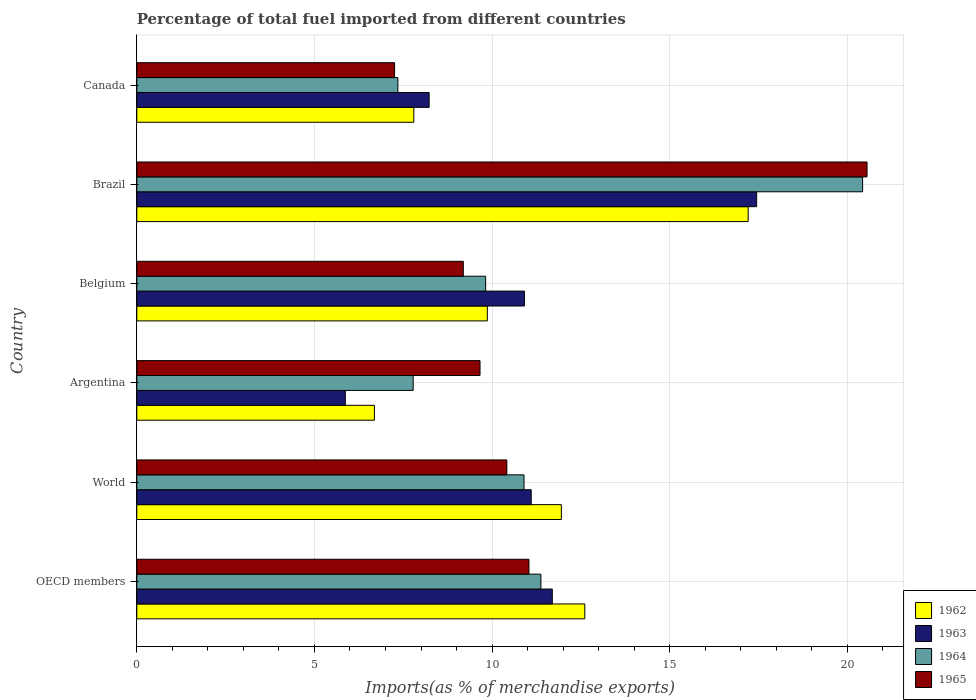How many different coloured bars are there?
Your response must be concise. 4. How many groups of bars are there?
Offer a very short reply. 6. Are the number of bars on each tick of the Y-axis equal?
Provide a succinct answer. Yes. How many bars are there on the 5th tick from the top?
Provide a succinct answer. 4. How many bars are there on the 6th tick from the bottom?
Give a very brief answer. 4. In how many cases, is the number of bars for a given country not equal to the number of legend labels?
Your answer should be compact. 0. What is the percentage of imports to different countries in 1965 in Belgium?
Your answer should be compact. 9.19. Across all countries, what is the maximum percentage of imports to different countries in 1965?
Ensure brevity in your answer.  20.55. Across all countries, what is the minimum percentage of imports to different countries in 1965?
Give a very brief answer. 7.26. In which country was the percentage of imports to different countries in 1964 maximum?
Provide a short and direct response. Brazil. In which country was the percentage of imports to different countries in 1962 minimum?
Provide a short and direct response. Argentina. What is the total percentage of imports to different countries in 1965 in the graph?
Ensure brevity in your answer.  68.12. What is the difference between the percentage of imports to different countries in 1962 in Belgium and that in Canada?
Make the answer very short. 2.07. What is the difference between the percentage of imports to different countries in 1962 in OECD members and the percentage of imports to different countries in 1964 in Canada?
Make the answer very short. 5.26. What is the average percentage of imports to different countries in 1964 per country?
Your answer should be very brief. 11.28. What is the difference between the percentage of imports to different countries in 1963 and percentage of imports to different countries in 1965 in World?
Your answer should be compact. 0.69. In how many countries, is the percentage of imports to different countries in 1965 greater than 7 %?
Ensure brevity in your answer.  6. What is the ratio of the percentage of imports to different countries in 1964 in Argentina to that in OECD members?
Give a very brief answer. 0.68. Is the percentage of imports to different countries in 1964 in OECD members less than that in World?
Your answer should be very brief. No. Is the difference between the percentage of imports to different countries in 1963 in Brazil and Canada greater than the difference between the percentage of imports to different countries in 1965 in Brazil and Canada?
Your response must be concise. No. What is the difference between the highest and the second highest percentage of imports to different countries in 1962?
Provide a succinct answer. 4.6. What is the difference between the highest and the lowest percentage of imports to different countries in 1965?
Your answer should be compact. 13.3. Is it the case that in every country, the sum of the percentage of imports to different countries in 1965 and percentage of imports to different countries in 1963 is greater than the sum of percentage of imports to different countries in 1962 and percentage of imports to different countries in 1964?
Provide a short and direct response. No. What does the 4th bar from the bottom in Belgium represents?
Provide a succinct answer. 1965. Is it the case that in every country, the sum of the percentage of imports to different countries in 1964 and percentage of imports to different countries in 1965 is greater than the percentage of imports to different countries in 1963?
Keep it short and to the point. Yes. How many bars are there?
Your answer should be compact. 24. Are all the bars in the graph horizontal?
Provide a short and direct response. Yes. Where does the legend appear in the graph?
Provide a short and direct response. Bottom right. How many legend labels are there?
Ensure brevity in your answer.  4. What is the title of the graph?
Your response must be concise. Percentage of total fuel imported from different countries. Does "1971" appear as one of the legend labels in the graph?
Make the answer very short. No. What is the label or title of the X-axis?
Offer a very short reply. Imports(as % of merchandise exports). What is the Imports(as % of merchandise exports) in 1962 in OECD members?
Offer a very short reply. 12.61. What is the Imports(as % of merchandise exports) of 1963 in OECD members?
Keep it short and to the point. 11.7. What is the Imports(as % of merchandise exports) in 1964 in OECD members?
Your response must be concise. 11.37. What is the Imports(as % of merchandise exports) of 1965 in OECD members?
Give a very brief answer. 11.04. What is the Imports(as % of merchandise exports) in 1962 in World?
Offer a very short reply. 11.95. What is the Imports(as % of merchandise exports) in 1963 in World?
Your response must be concise. 11.1. What is the Imports(as % of merchandise exports) of 1964 in World?
Your response must be concise. 10.9. What is the Imports(as % of merchandise exports) in 1965 in World?
Make the answer very short. 10.42. What is the Imports(as % of merchandise exports) of 1962 in Argentina?
Provide a short and direct response. 6.69. What is the Imports(as % of merchandise exports) of 1963 in Argentina?
Your response must be concise. 5.87. What is the Imports(as % of merchandise exports) of 1964 in Argentina?
Offer a terse response. 7.78. What is the Imports(as % of merchandise exports) in 1965 in Argentina?
Give a very brief answer. 9.66. What is the Imports(as % of merchandise exports) in 1962 in Belgium?
Make the answer very short. 9.87. What is the Imports(as % of merchandise exports) in 1963 in Belgium?
Keep it short and to the point. 10.91. What is the Imports(as % of merchandise exports) in 1964 in Belgium?
Ensure brevity in your answer.  9.82. What is the Imports(as % of merchandise exports) in 1965 in Belgium?
Provide a succinct answer. 9.19. What is the Imports(as % of merchandise exports) of 1962 in Brazil?
Ensure brevity in your answer.  17.21. What is the Imports(as % of merchandise exports) of 1963 in Brazil?
Your answer should be compact. 17.45. What is the Imports(as % of merchandise exports) of 1964 in Brazil?
Your response must be concise. 20.43. What is the Imports(as % of merchandise exports) of 1965 in Brazil?
Offer a very short reply. 20.55. What is the Imports(as % of merchandise exports) of 1962 in Canada?
Provide a succinct answer. 7.8. What is the Imports(as % of merchandise exports) of 1963 in Canada?
Give a very brief answer. 8.23. What is the Imports(as % of merchandise exports) of 1964 in Canada?
Provide a short and direct response. 7.35. What is the Imports(as % of merchandise exports) in 1965 in Canada?
Keep it short and to the point. 7.26. Across all countries, what is the maximum Imports(as % of merchandise exports) of 1962?
Provide a short and direct response. 17.21. Across all countries, what is the maximum Imports(as % of merchandise exports) in 1963?
Your answer should be compact. 17.45. Across all countries, what is the maximum Imports(as % of merchandise exports) in 1964?
Offer a terse response. 20.43. Across all countries, what is the maximum Imports(as % of merchandise exports) in 1965?
Keep it short and to the point. 20.55. Across all countries, what is the minimum Imports(as % of merchandise exports) of 1962?
Give a very brief answer. 6.69. Across all countries, what is the minimum Imports(as % of merchandise exports) of 1963?
Keep it short and to the point. 5.87. Across all countries, what is the minimum Imports(as % of merchandise exports) in 1964?
Your answer should be compact. 7.35. Across all countries, what is the minimum Imports(as % of merchandise exports) of 1965?
Provide a succinct answer. 7.26. What is the total Imports(as % of merchandise exports) of 1962 in the graph?
Ensure brevity in your answer.  66.12. What is the total Imports(as % of merchandise exports) in 1963 in the graph?
Give a very brief answer. 65.25. What is the total Imports(as % of merchandise exports) of 1964 in the graph?
Give a very brief answer. 67.65. What is the total Imports(as % of merchandise exports) of 1965 in the graph?
Keep it short and to the point. 68.12. What is the difference between the Imports(as % of merchandise exports) of 1962 in OECD members and that in World?
Your answer should be very brief. 0.66. What is the difference between the Imports(as % of merchandise exports) of 1963 in OECD members and that in World?
Offer a very short reply. 0.59. What is the difference between the Imports(as % of merchandise exports) in 1964 in OECD members and that in World?
Ensure brevity in your answer.  0.48. What is the difference between the Imports(as % of merchandise exports) of 1965 in OECD members and that in World?
Your answer should be very brief. 0.62. What is the difference between the Imports(as % of merchandise exports) in 1962 in OECD members and that in Argentina?
Your answer should be compact. 5.92. What is the difference between the Imports(as % of merchandise exports) in 1963 in OECD members and that in Argentina?
Provide a short and direct response. 5.83. What is the difference between the Imports(as % of merchandise exports) in 1964 in OECD members and that in Argentina?
Keep it short and to the point. 3.59. What is the difference between the Imports(as % of merchandise exports) in 1965 in OECD members and that in Argentina?
Give a very brief answer. 1.38. What is the difference between the Imports(as % of merchandise exports) of 1962 in OECD members and that in Belgium?
Your answer should be compact. 2.74. What is the difference between the Imports(as % of merchandise exports) in 1963 in OECD members and that in Belgium?
Provide a succinct answer. 0.79. What is the difference between the Imports(as % of merchandise exports) in 1964 in OECD members and that in Belgium?
Keep it short and to the point. 1.56. What is the difference between the Imports(as % of merchandise exports) of 1965 in OECD members and that in Belgium?
Provide a succinct answer. 1.85. What is the difference between the Imports(as % of merchandise exports) in 1962 in OECD members and that in Brazil?
Offer a very short reply. -4.6. What is the difference between the Imports(as % of merchandise exports) in 1963 in OECD members and that in Brazil?
Ensure brevity in your answer.  -5.75. What is the difference between the Imports(as % of merchandise exports) of 1964 in OECD members and that in Brazil?
Your response must be concise. -9.06. What is the difference between the Imports(as % of merchandise exports) in 1965 in OECD members and that in Brazil?
Ensure brevity in your answer.  -9.52. What is the difference between the Imports(as % of merchandise exports) in 1962 in OECD members and that in Canada?
Provide a succinct answer. 4.81. What is the difference between the Imports(as % of merchandise exports) of 1963 in OECD members and that in Canada?
Keep it short and to the point. 3.47. What is the difference between the Imports(as % of merchandise exports) of 1964 in OECD members and that in Canada?
Offer a very short reply. 4.03. What is the difference between the Imports(as % of merchandise exports) of 1965 in OECD members and that in Canada?
Your answer should be compact. 3.78. What is the difference between the Imports(as % of merchandise exports) of 1962 in World and that in Argentina?
Your answer should be very brief. 5.26. What is the difference between the Imports(as % of merchandise exports) in 1963 in World and that in Argentina?
Provide a succinct answer. 5.23. What is the difference between the Imports(as % of merchandise exports) of 1964 in World and that in Argentina?
Your answer should be very brief. 3.12. What is the difference between the Imports(as % of merchandise exports) of 1965 in World and that in Argentina?
Offer a terse response. 0.76. What is the difference between the Imports(as % of merchandise exports) in 1962 in World and that in Belgium?
Offer a terse response. 2.08. What is the difference between the Imports(as % of merchandise exports) in 1963 in World and that in Belgium?
Your answer should be compact. 0.19. What is the difference between the Imports(as % of merchandise exports) of 1964 in World and that in Belgium?
Keep it short and to the point. 1.08. What is the difference between the Imports(as % of merchandise exports) of 1965 in World and that in Belgium?
Your response must be concise. 1.23. What is the difference between the Imports(as % of merchandise exports) in 1962 in World and that in Brazil?
Keep it short and to the point. -5.26. What is the difference between the Imports(as % of merchandise exports) of 1963 in World and that in Brazil?
Provide a succinct answer. -6.34. What is the difference between the Imports(as % of merchandise exports) in 1964 in World and that in Brazil?
Your answer should be compact. -9.53. What is the difference between the Imports(as % of merchandise exports) of 1965 in World and that in Brazil?
Offer a very short reply. -10.14. What is the difference between the Imports(as % of merchandise exports) in 1962 in World and that in Canada?
Provide a succinct answer. 4.15. What is the difference between the Imports(as % of merchandise exports) of 1963 in World and that in Canada?
Ensure brevity in your answer.  2.87. What is the difference between the Imports(as % of merchandise exports) in 1964 in World and that in Canada?
Your answer should be compact. 3.55. What is the difference between the Imports(as % of merchandise exports) of 1965 in World and that in Canada?
Keep it short and to the point. 3.16. What is the difference between the Imports(as % of merchandise exports) of 1962 in Argentina and that in Belgium?
Provide a short and direct response. -3.18. What is the difference between the Imports(as % of merchandise exports) in 1963 in Argentina and that in Belgium?
Your answer should be very brief. -5.04. What is the difference between the Imports(as % of merchandise exports) of 1964 in Argentina and that in Belgium?
Provide a succinct answer. -2.04. What is the difference between the Imports(as % of merchandise exports) of 1965 in Argentina and that in Belgium?
Your answer should be very brief. 0.47. What is the difference between the Imports(as % of merchandise exports) of 1962 in Argentina and that in Brazil?
Your response must be concise. -10.52. What is the difference between the Imports(as % of merchandise exports) in 1963 in Argentina and that in Brazil?
Provide a short and direct response. -11.58. What is the difference between the Imports(as % of merchandise exports) of 1964 in Argentina and that in Brazil?
Provide a short and direct response. -12.65. What is the difference between the Imports(as % of merchandise exports) in 1965 in Argentina and that in Brazil?
Keep it short and to the point. -10.89. What is the difference between the Imports(as % of merchandise exports) in 1962 in Argentina and that in Canada?
Offer a very short reply. -1.11. What is the difference between the Imports(as % of merchandise exports) in 1963 in Argentina and that in Canada?
Provide a succinct answer. -2.36. What is the difference between the Imports(as % of merchandise exports) in 1964 in Argentina and that in Canada?
Offer a terse response. 0.43. What is the difference between the Imports(as % of merchandise exports) in 1965 in Argentina and that in Canada?
Ensure brevity in your answer.  2.4. What is the difference between the Imports(as % of merchandise exports) in 1962 in Belgium and that in Brazil?
Ensure brevity in your answer.  -7.34. What is the difference between the Imports(as % of merchandise exports) of 1963 in Belgium and that in Brazil?
Your answer should be compact. -6.54. What is the difference between the Imports(as % of merchandise exports) of 1964 in Belgium and that in Brazil?
Give a very brief answer. -10.61. What is the difference between the Imports(as % of merchandise exports) of 1965 in Belgium and that in Brazil?
Provide a short and direct response. -11.36. What is the difference between the Imports(as % of merchandise exports) of 1962 in Belgium and that in Canada?
Ensure brevity in your answer.  2.07. What is the difference between the Imports(as % of merchandise exports) of 1963 in Belgium and that in Canada?
Offer a terse response. 2.68. What is the difference between the Imports(as % of merchandise exports) in 1964 in Belgium and that in Canada?
Your answer should be compact. 2.47. What is the difference between the Imports(as % of merchandise exports) of 1965 in Belgium and that in Canada?
Ensure brevity in your answer.  1.93. What is the difference between the Imports(as % of merchandise exports) of 1962 in Brazil and that in Canada?
Keep it short and to the point. 9.41. What is the difference between the Imports(as % of merchandise exports) in 1963 in Brazil and that in Canada?
Offer a terse response. 9.22. What is the difference between the Imports(as % of merchandise exports) in 1964 in Brazil and that in Canada?
Make the answer very short. 13.08. What is the difference between the Imports(as % of merchandise exports) in 1965 in Brazil and that in Canada?
Your answer should be compact. 13.3. What is the difference between the Imports(as % of merchandise exports) of 1962 in OECD members and the Imports(as % of merchandise exports) of 1963 in World?
Offer a terse response. 1.51. What is the difference between the Imports(as % of merchandise exports) of 1962 in OECD members and the Imports(as % of merchandise exports) of 1964 in World?
Your answer should be very brief. 1.71. What is the difference between the Imports(as % of merchandise exports) in 1962 in OECD members and the Imports(as % of merchandise exports) in 1965 in World?
Make the answer very short. 2.19. What is the difference between the Imports(as % of merchandise exports) of 1963 in OECD members and the Imports(as % of merchandise exports) of 1964 in World?
Your response must be concise. 0.8. What is the difference between the Imports(as % of merchandise exports) in 1963 in OECD members and the Imports(as % of merchandise exports) in 1965 in World?
Offer a terse response. 1.28. What is the difference between the Imports(as % of merchandise exports) of 1964 in OECD members and the Imports(as % of merchandise exports) of 1965 in World?
Ensure brevity in your answer.  0.96. What is the difference between the Imports(as % of merchandise exports) of 1962 in OECD members and the Imports(as % of merchandise exports) of 1963 in Argentina?
Offer a very short reply. 6.74. What is the difference between the Imports(as % of merchandise exports) in 1962 in OECD members and the Imports(as % of merchandise exports) in 1964 in Argentina?
Ensure brevity in your answer.  4.83. What is the difference between the Imports(as % of merchandise exports) of 1962 in OECD members and the Imports(as % of merchandise exports) of 1965 in Argentina?
Give a very brief answer. 2.95. What is the difference between the Imports(as % of merchandise exports) of 1963 in OECD members and the Imports(as % of merchandise exports) of 1964 in Argentina?
Make the answer very short. 3.92. What is the difference between the Imports(as % of merchandise exports) in 1963 in OECD members and the Imports(as % of merchandise exports) in 1965 in Argentina?
Offer a very short reply. 2.04. What is the difference between the Imports(as % of merchandise exports) of 1964 in OECD members and the Imports(as % of merchandise exports) of 1965 in Argentina?
Provide a short and direct response. 1.71. What is the difference between the Imports(as % of merchandise exports) of 1962 in OECD members and the Imports(as % of merchandise exports) of 1963 in Belgium?
Your response must be concise. 1.7. What is the difference between the Imports(as % of merchandise exports) of 1962 in OECD members and the Imports(as % of merchandise exports) of 1964 in Belgium?
Provide a short and direct response. 2.79. What is the difference between the Imports(as % of merchandise exports) of 1962 in OECD members and the Imports(as % of merchandise exports) of 1965 in Belgium?
Provide a succinct answer. 3.42. What is the difference between the Imports(as % of merchandise exports) of 1963 in OECD members and the Imports(as % of merchandise exports) of 1964 in Belgium?
Offer a very short reply. 1.88. What is the difference between the Imports(as % of merchandise exports) in 1963 in OECD members and the Imports(as % of merchandise exports) in 1965 in Belgium?
Give a very brief answer. 2.51. What is the difference between the Imports(as % of merchandise exports) of 1964 in OECD members and the Imports(as % of merchandise exports) of 1965 in Belgium?
Make the answer very short. 2.18. What is the difference between the Imports(as % of merchandise exports) of 1962 in OECD members and the Imports(as % of merchandise exports) of 1963 in Brazil?
Your answer should be very brief. -4.84. What is the difference between the Imports(as % of merchandise exports) in 1962 in OECD members and the Imports(as % of merchandise exports) in 1964 in Brazil?
Give a very brief answer. -7.82. What is the difference between the Imports(as % of merchandise exports) of 1962 in OECD members and the Imports(as % of merchandise exports) of 1965 in Brazil?
Offer a very short reply. -7.94. What is the difference between the Imports(as % of merchandise exports) of 1963 in OECD members and the Imports(as % of merchandise exports) of 1964 in Brazil?
Keep it short and to the point. -8.73. What is the difference between the Imports(as % of merchandise exports) in 1963 in OECD members and the Imports(as % of merchandise exports) in 1965 in Brazil?
Ensure brevity in your answer.  -8.86. What is the difference between the Imports(as % of merchandise exports) of 1964 in OECD members and the Imports(as % of merchandise exports) of 1965 in Brazil?
Your response must be concise. -9.18. What is the difference between the Imports(as % of merchandise exports) in 1962 in OECD members and the Imports(as % of merchandise exports) in 1963 in Canada?
Offer a very short reply. 4.38. What is the difference between the Imports(as % of merchandise exports) of 1962 in OECD members and the Imports(as % of merchandise exports) of 1964 in Canada?
Keep it short and to the point. 5.26. What is the difference between the Imports(as % of merchandise exports) in 1962 in OECD members and the Imports(as % of merchandise exports) in 1965 in Canada?
Your answer should be compact. 5.35. What is the difference between the Imports(as % of merchandise exports) of 1963 in OECD members and the Imports(as % of merchandise exports) of 1964 in Canada?
Make the answer very short. 4.35. What is the difference between the Imports(as % of merchandise exports) of 1963 in OECD members and the Imports(as % of merchandise exports) of 1965 in Canada?
Ensure brevity in your answer.  4.44. What is the difference between the Imports(as % of merchandise exports) in 1964 in OECD members and the Imports(as % of merchandise exports) in 1965 in Canada?
Ensure brevity in your answer.  4.12. What is the difference between the Imports(as % of merchandise exports) in 1962 in World and the Imports(as % of merchandise exports) in 1963 in Argentina?
Your response must be concise. 6.08. What is the difference between the Imports(as % of merchandise exports) of 1962 in World and the Imports(as % of merchandise exports) of 1964 in Argentina?
Provide a succinct answer. 4.17. What is the difference between the Imports(as % of merchandise exports) of 1962 in World and the Imports(as % of merchandise exports) of 1965 in Argentina?
Make the answer very short. 2.29. What is the difference between the Imports(as % of merchandise exports) of 1963 in World and the Imports(as % of merchandise exports) of 1964 in Argentina?
Ensure brevity in your answer.  3.32. What is the difference between the Imports(as % of merchandise exports) of 1963 in World and the Imports(as % of merchandise exports) of 1965 in Argentina?
Ensure brevity in your answer.  1.44. What is the difference between the Imports(as % of merchandise exports) of 1964 in World and the Imports(as % of merchandise exports) of 1965 in Argentina?
Offer a terse response. 1.24. What is the difference between the Imports(as % of merchandise exports) in 1962 in World and the Imports(as % of merchandise exports) in 1963 in Belgium?
Provide a succinct answer. 1.04. What is the difference between the Imports(as % of merchandise exports) in 1962 in World and the Imports(as % of merchandise exports) in 1964 in Belgium?
Provide a short and direct response. 2.13. What is the difference between the Imports(as % of merchandise exports) in 1962 in World and the Imports(as % of merchandise exports) in 1965 in Belgium?
Offer a terse response. 2.76. What is the difference between the Imports(as % of merchandise exports) in 1963 in World and the Imports(as % of merchandise exports) in 1964 in Belgium?
Your answer should be very brief. 1.28. What is the difference between the Imports(as % of merchandise exports) in 1963 in World and the Imports(as % of merchandise exports) in 1965 in Belgium?
Provide a succinct answer. 1.91. What is the difference between the Imports(as % of merchandise exports) in 1964 in World and the Imports(as % of merchandise exports) in 1965 in Belgium?
Offer a terse response. 1.71. What is the difference between the Imports(as % of merchandise exports) in 1962 in World and the Imports(as % of merchandise exports) in 1963 in Brazil?
Keep it short and to the point. -5.5. What is the difference between the Imports(as % of merchandise exports) in 1962 in World and the Imports(as % of merchandise exports) in 1964 in Brazil?
Your answer should be compact. -8.48. What is the difference between the Imports(as % of merchandise exports) in 1962 in World and the Imports(as % of merchandise exports) in 1965 in Brazil?
Provide a succinct answer. -8.6. What is the difference between the Imports(as % of merchandise exports) of 1963 in World and the Imports(as % of merchandise exports) of 1964 in Brazil?
Keep it short and to the point. -9.33. What is the difference between the Imports(as % of merchandise exports) in 1963 in World and the Imports(as % of merchandise exports) in 1965 in Brazil?
Give a very brief answer. -9.45. What is the difference between the Imports(as % of merchandise exports) in 1964 in World and the Imports(as % of merchandise exports) in 1965 in Brazil?
Ensure brevity in your answer.  -9.66. What is the difference between the Imports(as % of merchandise exports) of 1962 in World and the Imports(as % of merchandise exports) of 1963 in Canada?
Provide a succinct answer. 3.72. What is the difference between the Imports(as % of merchandise exports) in 1962 in World and the Imports(as % of merchandise exports) in 1964 in Canada?
Make the answer very short. 4.6. What is the difference between the Imports(as % of merchandise exports) of 1962 in World and the Imports(as % of merchandise exports) of 1965 in Canada?
Give a very brief answer. 4.69. What is the difference between the Imports(as % of merchandise exports) in 1963 in World and the Imports(as % of merchandise exports) in 1964 in Canada?
Provide a succinct answer. 3.75. What is the difference between the Imports(as % of merchandise exports) in 1963 in World and the Imports(as % of merchandise exports) in 1965 in Canada?
Offer a very short reply. 3.85. What is the difference between the Imports(as % of merchandise exports) in 1964 in World and the Imports(as % of merchandise exports) in 1965 in Canada?
Your answer should be very brief. 3.64. What is the difference between the Imports(as % of merchandise exports) in 1962 in Argentina and the Imports(as % of merchandise exports) in 1963 in Belgium?
Your answer should be very brief. -4.22. What is the difference between the Imports(as % of merchandise exports) of 1962 in Argentina and the Imports(as % of merchandise exports) of 1964 in Belgium?
Offer a very short reply. -3.13. What is the difference between the Imports(as % of merchandise exports) of 1962 in Argentina and the Imports(as % of merchandise exports) of 1965 in Belgium?
Your response must be concise. -2.5. What is the difference between the Imports(as % of merchandise exports) of 1963 in Argentina and the Imports(as % of merchandise exports) of 1964 in Belgium?
Keep it short and to the point. -3.95. What is the difference between the Imports(as % of merchandise exports) of 1963 in Argentina and the Imports(as % of merchandise exports) of 1965 in Belgium?
Provide a short and direct response. -3.32. What is the difference between the Imports(as % of merchandise exports) in 1964 in Argentina and the Imports(as % of merchandise exports) in 1965 in Belgium?
Offer a terse response. -1.41. What is the difference between the Imports(as % of merchandise exports) of 1962 in Argentina and the Imports(as % of merchandise exports) of 1963 in Brazil?
Your response must be concise. -10.76. What is the difference between the Imports(as % of merchandise exports) in 1962 in Argentina and the Imports(as % of merchandise exports) in 1964 in Brazil?
Your response must be concise. -13.74. What is the difference between the Imports(as % of merchandise exports) in 1962 in Argentina and the Imports(as % of merchandise exports) in 1965 in Brazil?
Offer a terse response. -13.87. What is the difference between the Imports(as % of merchandise exports) of 1963 in Argentina and the Imports(as % of merchandise exports) of 1964 in Brazil?
Offer a terse response. -14.56. What is the difference between the Imports(as % of merchandise exports) of 1963 in Argentina and the Imports(as % of merchandise exports) of 1965 in Brazil?
Offer a very short reply. -14.68. What is the difference between the Imports(as % of merchandise exports) in 1964 in Argentina and the Imports(as % of merchandise exports) in 1965 in Brazil?
Keep it short and to the point. -12.77. What is the difference between the Imports(as % of merchandise exports) in 1962 in Argentina and the Imports(as % of merchandise exports) in 1963 in Canada?
Provide a short and direct response. -1.54. What is the difference between the Imports(as % of merchandise exports) in 1962 in Argentina and the Imports(as % of merchandise exports) in 1964 in Canada?
Keep it short and to the point. -0.66. What is the difference between the Imports(as % of merchandise exports) of 1962 in Argentina and the Imports(as % of merchandise exports) of 1965 in Canada?
Offer a terse response. -0.57. What is the difference between the Imports(as % of merchandise exports) in 1963 in Argentina and the Imports(as % of merchandise exports) in 1964 in Canada?
Offer a very short reply. -1.48. What is the difference between the Imports(as % of merchandise exports) of 1963 in Argentina and the Imports(as % of merchandise exports) of 1965 in Canada?
Offer a terse response. -1.39. What is the difference between the Imports(as % of merchandise exports) in 1964 in Argentina and the Imports(as % of merchandise exports) in 1965 in Canada?
Offer a very short reply. 0.52. What is the difference between the Imports(as % of merchandise exports) in 1962 in Belgium and the Imports(as % of merchandise exports) in 1963 in Brazil?
Give a very brief answer. -7.58. What is the difference between the Imports(as % of merchandise exports) in 1962 in Belgium and the Imports(as % of merchandise exports) in 1964 in Brazil?
Your answer should be very brief. -10.56. What is the difference between the Imports(as % of merchandise exports) in 1962 in Belgium and the Imports(as % of merchandise exports) in 1965 in Brazil?
Ensure brevity in your answer.  -10.69. What is the difference between the Imports(as % of merchandise exports) in 1963 in Belgium and the Imports(as % of merchandise exports) in 1964 in Brazil?
Offer a terse response. -9.52. What is the difference between the Imports(as % of merchandise exports) in 1963 in Belgium and the Imports(as % of merchandise exports) in 1965 in Brazil?
Provide a short and direct response. -9.64. What is the difference between the Imports(as % of merchandise exports) of 1964 in Belgium and the Imports(as % of merchandise exports) of 1965 in Brazil?
Keep it short and to the point. -10.74. What is the difference between the Imports(as % of merchandise exports) of 1962 in Belgium and the Imports(as % of merchandise exports) of 1963 in Canada?
Provide a short and direct response. 1.64. What is the difference between the Imports(as % of merchandise exports) in 1962 in Belgium and the Imports(as % of merchandise exports) in 1964 in Canada?
Offer a very short reply. 2.52. What is the difference between the Imports(as % of merchandise exports) in 1962 in Belgium and the Imports(as % of merchandise exports) in 1965 in Canada?
Offer a terse response. 2.61. What is the difference between the Imports(as % of merchandise exports) of 1963 in Belgium and the Imports(as % of merchandise exports) of 1964 in Canada?
Provide a short and direct response. 3.56. What is the difference between the Imports(as % of merchandise exports) in 1963 in Belgium and the Imports(as % of merchandise exports) in 1965 in Canada?
Offer a very short reply. 3.65. What is the difference between the Imports(as % of merchandise exports) in 1964 in Belgium and the Imports(as % of merchandise exports) in 1965 in Canada?
Offer a very short reply. 2.56. What is the difference between the Imports(as % of merchandise exports) of 1962 in Brazil and the Imports(as % of merchandise exports) of 1963 in Canada?
Make the answer very short. 8.98. What is the difference between the Imports(as % of merchandise exports) of 1962 in Brazil and the Imports(as % of merchandise exports) of 1964 in Canada?
Ensure brevity in your answer.  9.86. What is the difference between the Imports(as % of merchandise exports) in 1962 in Brazil and the Imports(as % of merchandise exports) in 1965 in Canada?
Provide a short and direct response. 9.95. What is the difference between the Imports(as % of merchandise exports) of 1963 in Brazil and the Imports(as % of merchandise exports) of 1964 in Canada?
Ensure brevity in your answer.  10.1. What is the difference between the Imports(as % of merchandise exports) in 1963 in Brazil and the Imports(as % of merchandise exports) in 1965 in Canada?
Ensure brevity in your answer.  10.19. What is the difference between the Imports(as % of merchandise exports) of 1964 in Brazil and the Imports(as % of merchandise exports) of 1965 in Canada?
Offer a very short reply. 13.17. What is the average Imports(as % of merchandise exports) in 1962 per country?
Provide a succinct answer. 11.02. What is the average Imports(as % of merchandise exports) in 1963 per country?
Make the answer very short. 10.88. What is the average Imports(as % of merchandise exports) of 1964 per country?
Offer a very short reply. 11.28. What is the average Imports(as % of merchandise exports) of 1965 per country?
Your answer should be very brief. 11.35. What is the difference between the Imports(as % of merchandise exports) in 1962 and Imports(as % of merchandise exports) in 1963 in OECD members?
Keep it short and to the point. 0.91. What is the difference between the Imports(as % of merchandise exports) in 1962 and Imports(as % of merchandise exports) in 1964 in OECD members?
Ensure brevity in your answer.  1.24. What is the difference between the Imports(as % of merchandise exports) of 1962 and Imports(as % of merchandise exports) of 1965 in OECD members?
Your answer should be compact. 1.57. What is the difference between the Imports(as % of merchandise exports) of 1963 and Imports(as % of merchandise exports) of 1964 in OECD members?
Offer a very short reply. 0.32. What is the difference between the Imports(as % of merchandise exports) in 1963 and Imports(as % of merchandise exports) in 1965 in OECD members?
Your answer should be compact. 0.66. What is the difference between the Imports(as % of merchandise exports) of 1964 and Imports(as % of merchandise exports) of 1965 in OECD members?
Your answer should be compact. 0.34. What is the difference between the Imports(as % of merchandise exports) of 1962 and Imports(as % of merchandise exports) of 1963 in World?
Provide a succinct answer. 0.85. What is the difference between the Imports(as % of merchandise exports) in 1962 and Imports(as % of merchandise exports) in 1964 in World?
Your answer should be compact. 1.05. What is the difference between the Imports(as % of merchandise exports) of 1962 and Imports(as % of merchandise exports) of 1965 in World?
Provide a succinct answer. 1.53. What is the difference between the Imports(as % of merchandise exports) in 1963 and Imports(as % of merchandise exports) in 1964 in World?
Ensure brevity in your answer.  0.2. What is the difference between the Imports(as % of merchandise exports) of 1963 and Imports(as % of merchandise exports) of 1965 in World?
Your response must be concise. 0.69. What is the difference between the Imports(as % of merchandise exports) in 1964 and Imports(as % of merchandise exports) in 1965 in World?
Keep it short and to the point. 0.48. What is the difference between the Imports(as % of merchandise exports) in 1962 and Imports(as % of merchandise exports) in 1963 in Argentina?
Make the answer very short. 0.82. What is the difference between the Imports(as % of merchandise exports) of 1962 and Imports(as % of merchandise exports) of 1964 in Argentina?
Your answer should be very brief. -1.09. What is the difference between the Imports(as % of merchandise exports) in 1962 and Imports(as % of merchandise exports) in 1965 in Argentina?
Ensure brevity in your answer.  -2.97. What is the difference between the Imports(as % of merchandise exports) of 1963 and Imports(as % of merchandise exports) of 1964 in Argentina?
Make the answer very short. -1.91. What is the difference between the Imports(as % of merchandise exports) of 1963 and Imports(as % of merchandise exports) of 1965 in Argentina?
Your answer should be very brief. -3.79. What is the difference between the Imports(as % of merchandise exports) of 1964 and Imports(as % of merchandise exports) of 1965 in Argentina?
Make the answer very short. -1.88. What is the difference between the Imports(as % of merchandise exports) in 1962 and Imports(as % of merchandise exports) in 1963 in Belgium?
Offer a terse response. -1.04. What is the difference between the Imports(as % of merchandise exports) in 1962 and Imports(as % of merchandise exports) in 1964 in Belgium?
Make the answer very short. 0.05. What is the difference between the Imports(as % of merchandise exports) of 1962 and Imports(as % of merchandise exports) of 1965 in Belgium?
Keep it short and to the point. 0.68. What is the difference between the Imports(as % of merchandise exports) in 1963 and Imports(as % of merchandise exports) in 1964 in Belgium?
Make the answer very short. 1.09. What is the difference between the Imports(as % of merchandise exports) in 1963 and Imports(as % of merchandise exports) in 1965 in Belgium?
Give a very brief answer. 1.72. What is the difference between the Imports(as % of merchandise exports) in 1964 and Imports(as % of merchandise exports) in 1965 in Belgium?
Make the answer very short. 0.63. What is the difference between the Imports(as % of merchandise exports) of 1962 and Imports(as % of merchandise exports) of 1963 in Brazil?
Your response must be concise. -0.24. What is the difference between the Imports(as % of merchandise exports) of 1962 and Imports(as % of merchandise exports) of 1964 in Brazil?
Give a very brief answer. -3.22. What is the difference between the Imports(as % of merchandise exports) of 1962 and Imports(as % of merchandise exports) of 1965 in Brazil?
Give a very brief answer. -3.35. What is the difference between the Imports(as % of merchandise exports) in 1963 and Imports(as % of merchandise exports) in 1964 in Brazil?
Provide a succinct answer. -2.98. What is the difference between the Imports(as % of merchandise exports) in 1963 and Imports(as % of merchandise exports) in 1965 in Brazil?
Your answer should be compact. -3.11. What is the difference between the Imports(as % of merchandise exports) of 1964 and Imports(as % of merchandise exports) of 1965 in Brazil?
Give a very brief answer. -0.12. What is the difference between the Imports(as % of merchandise exports) in 1962 and Imports(as % of merchandise exports) in 1963 in Canada?
Your response must be concise. -0.43. What is the difference between the Imports(as % of merchandise exports) in 1962 and Imports(as % of merchandise exports) in 1964 in Canada?
Give a very brief answer. 0.45. What is the difference between the Imports(as % of merchandise exports) in 1962 and Imports(as % of merchandise exports) in 1965 in Canada?
Your answer should be compact. 0.54. What is the difference between the Imports(as % of merchandise exports) of 1963 and Imports(as % of merchandise exports) of 1964 in Canada?
Provide a short and direct response. 0.88. What is the difference between the Imports(as % of merchandise exports) in 1963 and Imports(as % of merchandise exports) in 1965 in Canada?
Provide a short and direct response. 0.97. What is the difference between the Imports(as % of merchandise exports) of 1964 and Imports(as % of merchandise exports) of 1965 in Canada?
Offer a very short reply. 0.09. What is the ratio of the Imports(as % of merchandise exports) in 1962 in OECD members to that in World?
Provide a succinct answer. 1.06. What is the ratio of the Imports(as % of merchandise exports) in 1963 in OECD members to that in World?
Your response must be concise. 1.05. What is the ratio of the Imports(as % of merchandise exports) in 1964 in OECD members to that in World?
Offer a very short reply. 1.04. What is the ratio of the Imports(as % of merchandise exports) of 1965 in OECD members to that in World?
Offer a terse response. 1.06. What is the ratio of the Imports(as % of merchandise exports) in 1962 in OECD members to that in Argentina?
Offer a very short reply. 1.89. What is the ratio of the Imports(as % of merchandise exports) in 1963 in OECD members to that in Argentina?
Offer a terse response. 1.99. What is the ratio of the Imports(as % of merchandise exports) of 1964 in OECD members to that in Argentina?
Provide a short and direct response. 1.46. What is the ratio of the Imports(as % of merchandise exports) in 1965 in OECD members to that in Argentina?
Provide a short and direct response. 1.14. What is the ratio of the Imports(as % of merchandise exports) in 1962 in OECD members to that in Belgium?
Your answer should be very brief. 1.28. What is the ratio of the Imports(as % of merchandise exports) in 1963 in OECD members to that in Belgium?
Ensure brevity in your answer.  1.07. What is the ratio of the Imports(as % of merchandise exports) of 1964 in OECD members to that in Belgium?
Ensure brevity in your answer.  1.16. What is the ratio of the Imports(as % of merchandise exports) of 1965 in OECD members to that in Belgium?
Ensure brevity in your answer.  1.2. What is the ratio of the Imports(as % of merchandise exports) in 1962 in OECD members to that in Brazil?
Offer a terse response. 0.73. What is the ratio of the Imports(as % of merchandise exports) of 1963 in OECD members to that in Brazil?
Provide a short and direct response. 0.67. What is the ratio of the Imports(as % of merchandise exports) in 1964 in OECD members to that in Brazil?
Provide a short and direct response. 0.56. What is the ratio of the Imports(as % of merchandise exports) of 1965 in OECD members to that in Brazil?
Provide a short and direct response. 0.54. What is the ratio of the Imports(as % of merchandise exports) of 1962 in OECD members to that in Canada?
Offer a very short reply. 1.62. What is the ratio of the Imports(as % of merchandise exports) of 1963 in OECD members to that in Canada?
Offer a very short reply. 1.42. What is the ratio of the Imports(as % of merchandise exports) in 1964 in OECD members to that in Canada?
Keep it short and to the point. 1.55. What is the ratio of the Imports(as % of merchandise exports) in 1965 in OECD members to that in Canada?
Provide a short and direct response. 1.52. What is the ratio of the Imports(as % of merchandise exports) in 1962 in World to that in Argentina?
Offer a terse response. 1.79. What is the ratio of the Imports(as % of merchandise exports) in 1963 in World to that in Argentina?
Your answer should be compact. 1.89. What is the ratio of the Imports(as % of merchandise exports) in 1964 in World to that in Argentina?
Offer a very short reply. 1.4. What is the ratio of the Imports(as % of merchandise exports) of 1965 in World to that in Argentina?
Provide a succinct answer. 1.08. What is the ratio of the Imports(as % of merchandise exports) in 1962 in World to that in Belgium?
Keep it short and to the point. 1.21. What is the ratio of the Imports(as % of merchandise exports) in 1963 in World to that in Belgium?
Your response must be concise. 1.02. What is the ratio of the Imports(as % of merchandise exports) of 1964 in World to that in Belgium?
Offer a very short reply. 1.11. What is the ratio of the Imports(as % of merchandise exports) of 1965 in World to that in Belgium?
Keep it short and to the point. 1.13. What is the ratio of the Imports(as % of merchandise exports) of 1962 in World to that in Brazil?
Your response must be concise. 0.69. What is the ratio of the Imports(as % of merchandise exports) in 1963 in World to that in Brazil?
Give a very brief answer. 0.64. What is the ratio of the Imports(as % of merchandise exports) of 1964 in World to that in Brazil?
Your answer should be very brief. 0.53. What is the ratio of the Imports(as % of merchandise exports) in 1965 in World to that in Brazil?
Provide a succinct answer. 0.51. What is the ratio of the Imports(as % of merchandise exports) in 1962 in World to that in Canada?
Keep it short and to the point. 1.53. What is the ratio of the Imports(as % of merchandise exports) in 1963 in World to that in Canada?
Keep it short and to the point. 1.35. What is the ratio of the Imports(as % of merchandise exports) of 1964 in World to that in Canada?
Your response must be concise. 1.48. What is the ratio of the Imports(as % of merchandise exports) of 1965 in World to that in Canada?
Make the answer very short. 1.44. What is the ratio of the Imports(as % of merchandise exports) in 1962 in Argentina to that in Belgium?
Give a very brief answer. 0.68. What is the ratio of the Imports(as % of merchandise exports) of 1963 in Argentina to that in Belgium?
Offer a terse response. 0.54. What is the ratio of the Imports(as % of merchandise exports) of 1964 in Argentina to that in Belgium?
Your answer should be compact. 0.79. What is the ratio of the Imports(as % of merchandise exports) in 1965 in Argentina to that in Belgium?
Your response must be concise. 1.05. What is the ratio of the Imports(as % of merchandise exports) in 1962 in Argentina to that in Brazil?
Keep it short and to the point. 0.39. What is the ratio of the Imports(as % of merchandise exports) in 1963 in Argentina to that in Brazil?
Offer a terse response. 0.34. What is the ratio of the Imports(as % of merchandise exports) in 1964 in Argentina to that in Brazil?
Provide a short and direct response. 0.38. What is the ratio of the Imports(as % of merchandise exports) in 1965 in Argentina to that in Brazil?
Offer a very short reply. 0.47. What is the ratio of the Imports(as % of merchandise exports) of 1962 in Argentina to that in Canada?
Your answer should be very brief. 0.86. What is the ratio of the Imports(as % of merchandise exports) in 1963 in Argentina to that in Canada?
Provide a short and direct response. 0.71. What is the ratio of the Imports(as % of merchandise exports) in 1964 in Argentina to that in Canada?
Provide a short and direct response. 1.06. What is the ratio of the Imports(as % of merchandise exports) in 1965 in Argentina to that in Canada?
Give a very brief answer. 1.33. What is the ratio of the Imports(as % of merchandise exports) of 1962 in Belgium to that in Brazil?
Your response must be concise. 0.57. What is the ratio of the Imports(as % of merchandise exports) of 1963 in Belgium to that in Brazil?
Give a very brief answer. 0.63. What is the ratio of the Imports(as % of merchandise exports) in 1964 in Belgium to that in Brazil?
Your answer should be very brief. 0.48. What is the ratio of the Imports(as % of merchandise exports) of 1965 in Belgium to that in Brazil?
Give a very brief answer. 0.45. What is the ratio of the Imports(as % of merchandise exports) of 1962 in Belgium to that in Canada?
Provide a short and direct response. 1.27. What is the ratio of the Imports(as % of merchandise exports) of 1963 in Belgium to that in Canada?
Your answer should be very brief. 1.33. What is the ratio of the Imports(as % of merchandise exports) in 1964 in Belgium to that in Canada?
Your response must be concise. 1.34. What is the ratio of the Imports(as % of merchandise exports) of 1965 in Belgium to that in Canada?
Your answer should be compact. 1.27. What is the ratio of the Imports(as % of merchandise exports) in 1962 in Brazil to that in Canada?
Provide a short and direct response. 2.21. What is the ratio of the Imports(as % of merchandise exports) of 1963 in Brazil to that in Canada?
Provide a short and direct response. 2.12. What is the ratio of the Imports(as % of merchandise exports) in 1964 in Brazil to that in Canada?
Give a very brief answer. 2.78. What is the ratio of the Imports(as % of merchandise exports) of 1965 in Brazil to that in Canada?
Offer a very short reply. 2.83. What is the difference between the highest and the second highest Imports(as % of merchandise exports) in 1962?
Your answer should be compact. 4.6. What is the difference between the highest and the second highest Imports(as % of merchandise exports) of 1963?
Your response must be concise. 5.75. What is the difference between the highest and the second highest Imports(as % of merchandise exports) of 1964?
Your answer should be very brief. 9.06. What is the difference between the highest and the second highest Imports(as % of merchandise exports) of 1965?
Provide a short and direct response. 9.52. What is the difference between the highest and the lowest Imports(as % of merchandise exports) in 1962?
Your answer should be compact. 10.52. What is the difference between the highest and the lowest Imports(as % of merchandise exports) in 1963?
Your response must be concise. 11.58. What is the difference between the highest and the lowest Imports(as % of merchandise exports) of 1964?
Offer a very short reply. 13.08. What is the difference between the highest and the lowest Imports(as % of merchandise exports) in 1965?
Give a very brief answer. 13.3. 